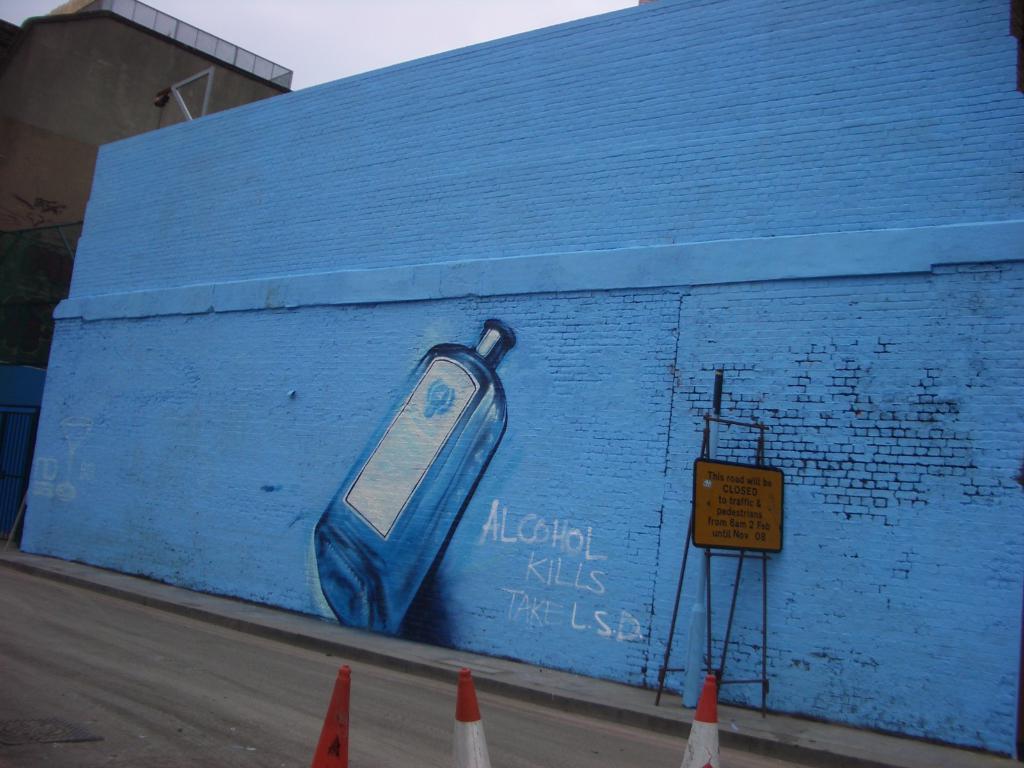How many traffic cone are in the picture?
Offer a terse response. Answering does not require reading text in the image. 